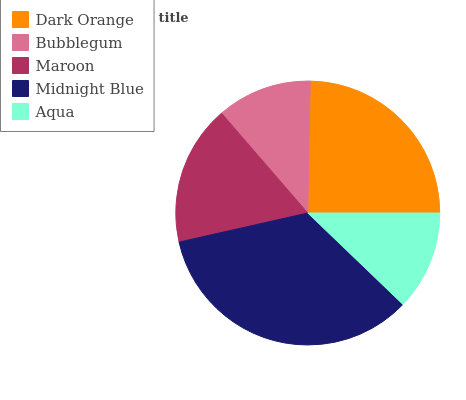Is Bubblegum the minimum?
Answer yes or no. Yes. Is Midnight Blue the maximum?
Answer yes or no. Yes. Is Maroon the minimum?
Answer yes or no. No. Is Maroon the maximum?
Answer yes or no. No. Is Maroon greater than Bubblegum?
Answer yes or no. Yes. Is Bubblegum less than Maroon?
Answer yes or no. Yes. Is Bubblegum greater than Maroon?
Answer yes or no. No. Is Maroon less than Bubblegum?
Answer yes or no. No. Is Maroon the high median?
Answer yes or no. Yes. Is Maroon the low median?
Answer yes or no. Yes. Is Aqua the high median?
Answer yes or no. No. Is Aqua the low median?
Answer yes or no. No. 